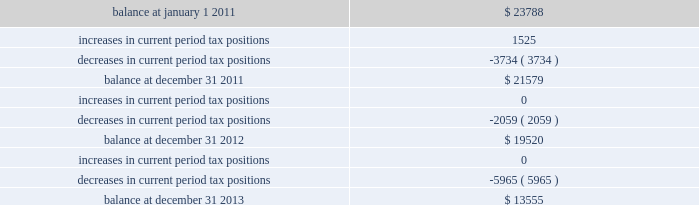The table summarizes the changes in the company 2019s valuation allowance: .
Included in 2013 is a discrete tax benefit totaling $ 2979 associated with an entity re-organization within the company 2019s market-based segment that allowed for the utilization of state net operating loss carryforwards and the release of an associated valuation allowance .
Note 14 : employee benefits pension and other postretirement benefits the company maintains noncontributory defined benefit pension plans covering eligible employees of its regulated utility and shared services operations .
Benefits under the plans are based on the employee 2019s years of service and compensation .
The pension plans have been closed for all employees .
The pension plans were closed for most employees hired on or after january 1 , 2006 .
Union employees hired on or after january 1 , 2001 had their accrued benefit frozen and will be able to receive this benefit as a lump sum upon termination or retirement .
Union employees hired on or after january 1 , 2001 and non-union employees hired on or after january 1 , 2006 are provided with a 5.25% ( 5.25 % ) of base pay defined contribution plan .
The company does not participate in a multiemployer plan .
The company 2019s pension funding practice is to contribute at least the greater of the minimum amount required by the employee retirement income security act of 1974 or the normal cost .
Further , the company will consider additional contributions if needed to avoid 201cat risk 201d status and benefit restrictions under the pension protection act of 2006 .
The company may also consider increased contributions , based on other financial requirements and the plans 2019 funded position .
Pension plan assets are invested in a number of actively managed and indexed investments including equity and bond mutual funds , fixed income securities , guaranteed interest contracts with insurance companies and real estate investment trusts ( 201creits 201d ) .
Pension expense in excess of the amount contributed to the pension plans is deferred by certain regulated subsidiaries pending future recovery in rates charged for utility services as contributions are made to the plans .
( see note 6 ) the company also has unfunded noncontributory supplemental non-qualified pension plans that provide additional retirement benefits to certain employees .
The company maintains other postretirement benefit plans providing varying levels of medical and life insurance to eligible retirees .
The retiree welfare plans are closed for union employees hired on or after january 1 , 2006 .
The plans had previously closed for non-union employees hired on or after january 1 , 2002 .
The company 2019s policy is to fund other postretirement benefit costs for rate-making purposes .
Assets of the plans are invested in equity mutual funds , bond mutual funds and fixed income securities. .
By how much did the company's valuation allowance change from 2012 to 2013? 
Computations: (-5965 / 19520)
Answer: -0.30558. 